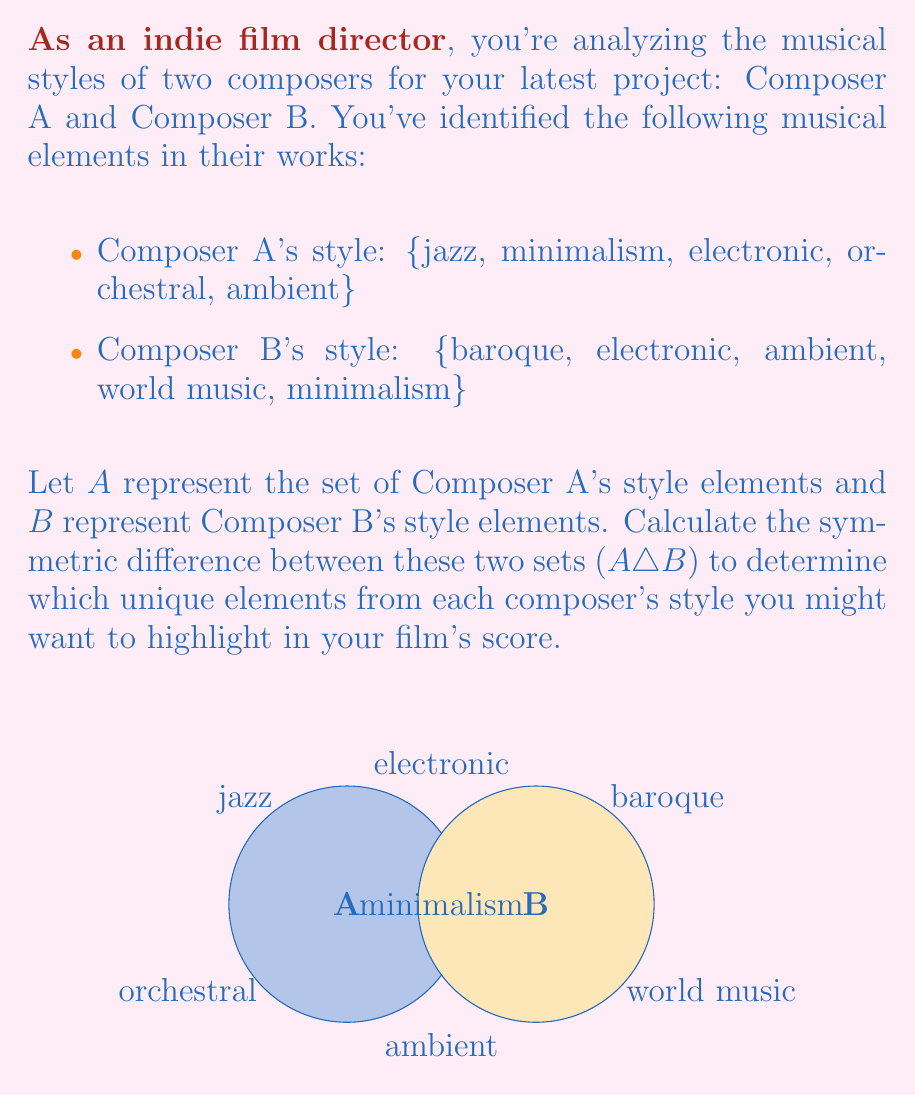Can you solve this math problem? To solve this problem, we need to understand the concept of symmetric difference and then apply it to the given sets.

1) The symmetric difference of two sets $A$ and $B$, denoted as $A \triangle B$, is defined as the set of elements that are in either $A$ or $B$, but not in both. It can be expressed as:

   $A \triangle B = (A \setminus B) \cup (B \setminus A)$

   where $\setminus$ denotes set difference.

2) Let's identify the elements in each set:
   $A = \{\text{jazz}, \text{minimalism}, \text{electronic}, \text{orchestral}, \text{ambient}\}$
   $B = \{\text{baroque}, \text{electronic}, \text{ambient}, \text{world music}, \text{minimalism}\}$

3) Now, let's find $A \setminus B$ (elements in $A$ but not in $B$):
   $A \setminus B = \{\text{jazz}, \text{orchestral}\}$

4) Next, let's find $B \setminus A$ (elements in $B$ but not in $A$):
   $B \setminus A = \{\text{baroque}, \text{world music}\}$

5) The symmetric difference is the union of these two sets:
   $A \triangle B = (A \setminus B) \cup (B \setminus A)$
                 $= \{\text{jazz}, \text{orchestral}\} \cup \{\text{baroque}, \text{world music}\}$
                 $= \{\text{jazz}, \text{orchestral}, \text{baroque}, \text{world music}\}$

Therefore, the symmetric difference contains the unique elements from each composer's style that are not shared by both.
Answer: $\{\text{jazz}, \text{orchestral}, \text{baroque}, \text{world music}\}$ 